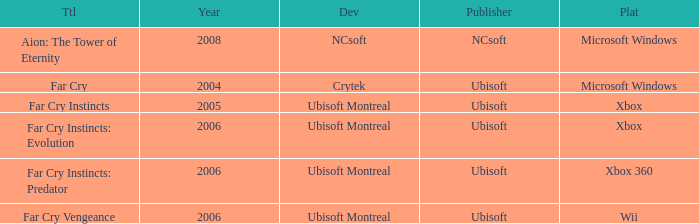What is the mean year featuring far cry vengeance as the title? 2006.0. 